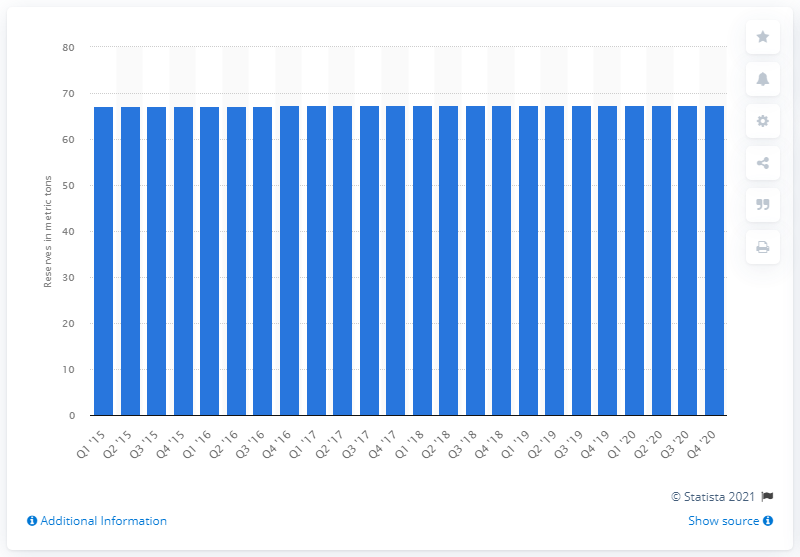Give some essential details in this illustration. In 2015, Brazil's Central Bank held a total of 67.2 tons of gold. 